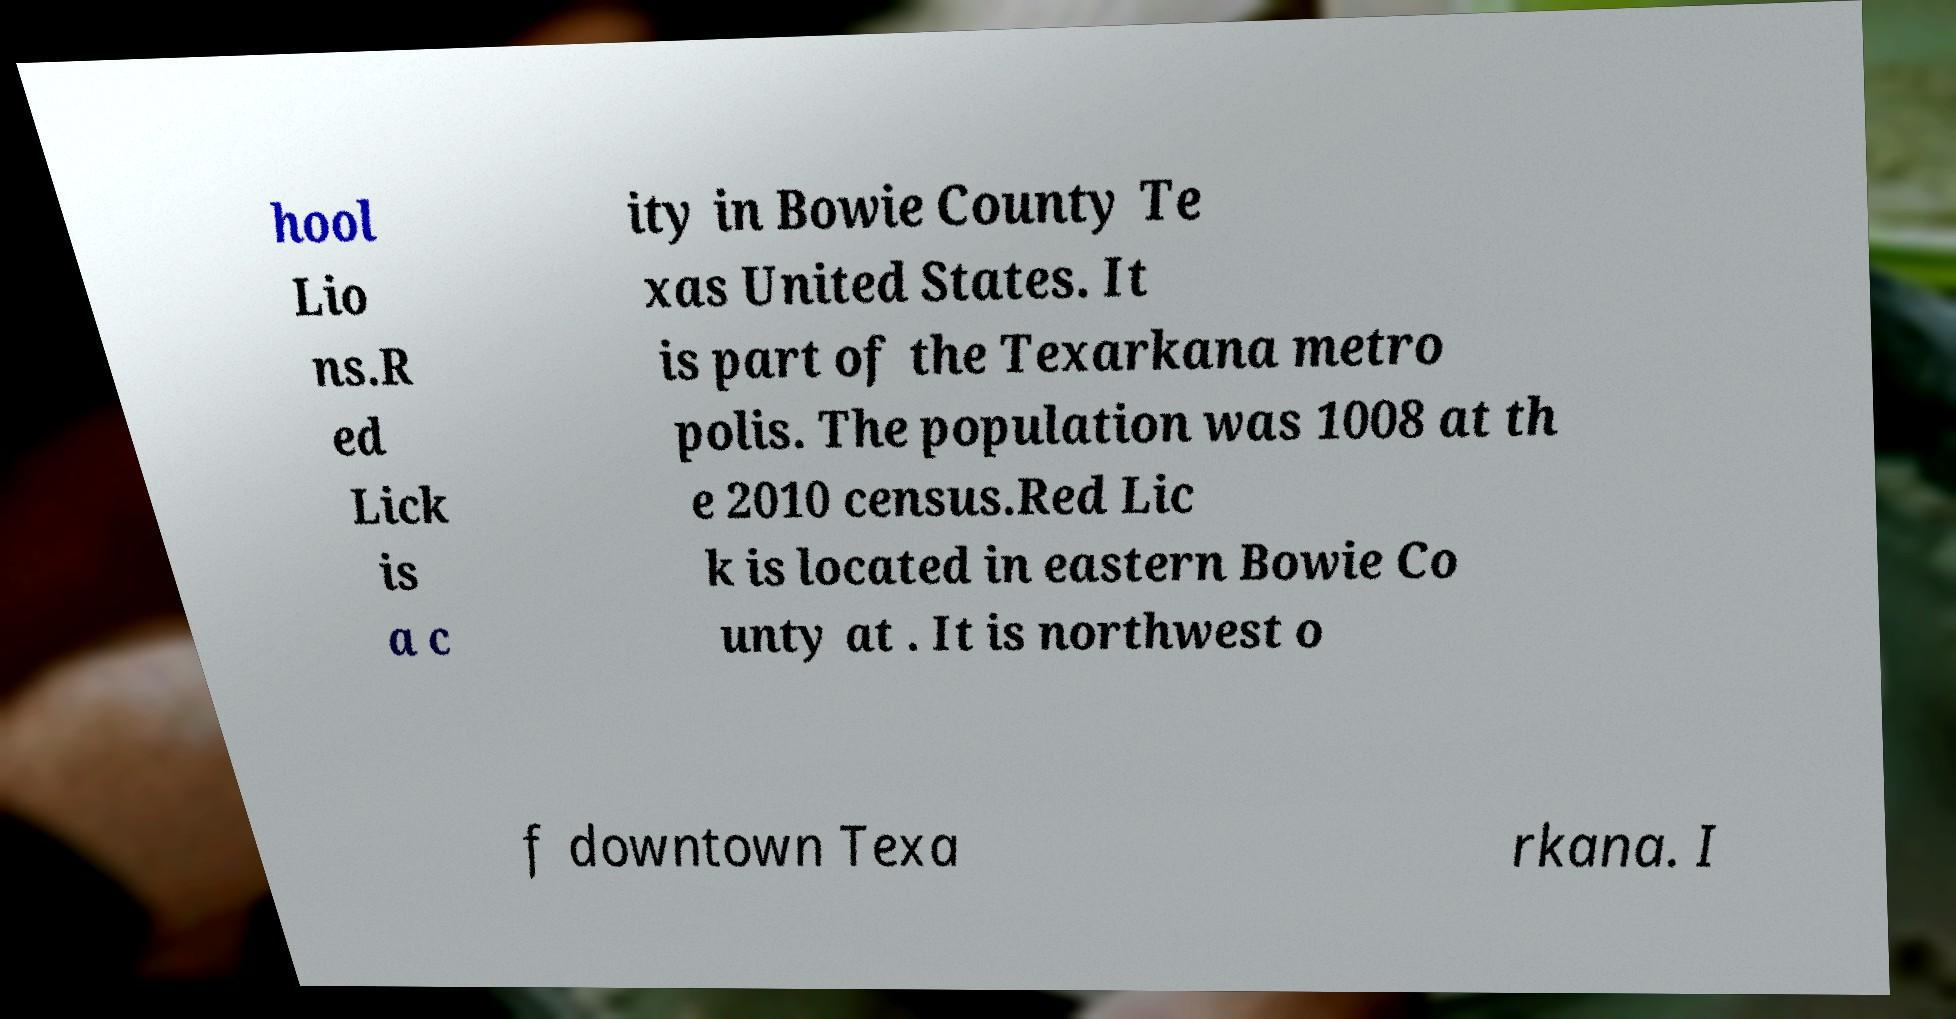For documentation purposes, I need the text within this image transcribed. Could you provide that? hool Lio ns.R ed Lick is a c ity in Bowie County Te xas United States. It is part of the Texarkana metro polis. The population was 1008 at th e 2010 census.Red Lic k is located in eastern Bowie Co unty at . It is northwest o f downtown Texa rkana. I 